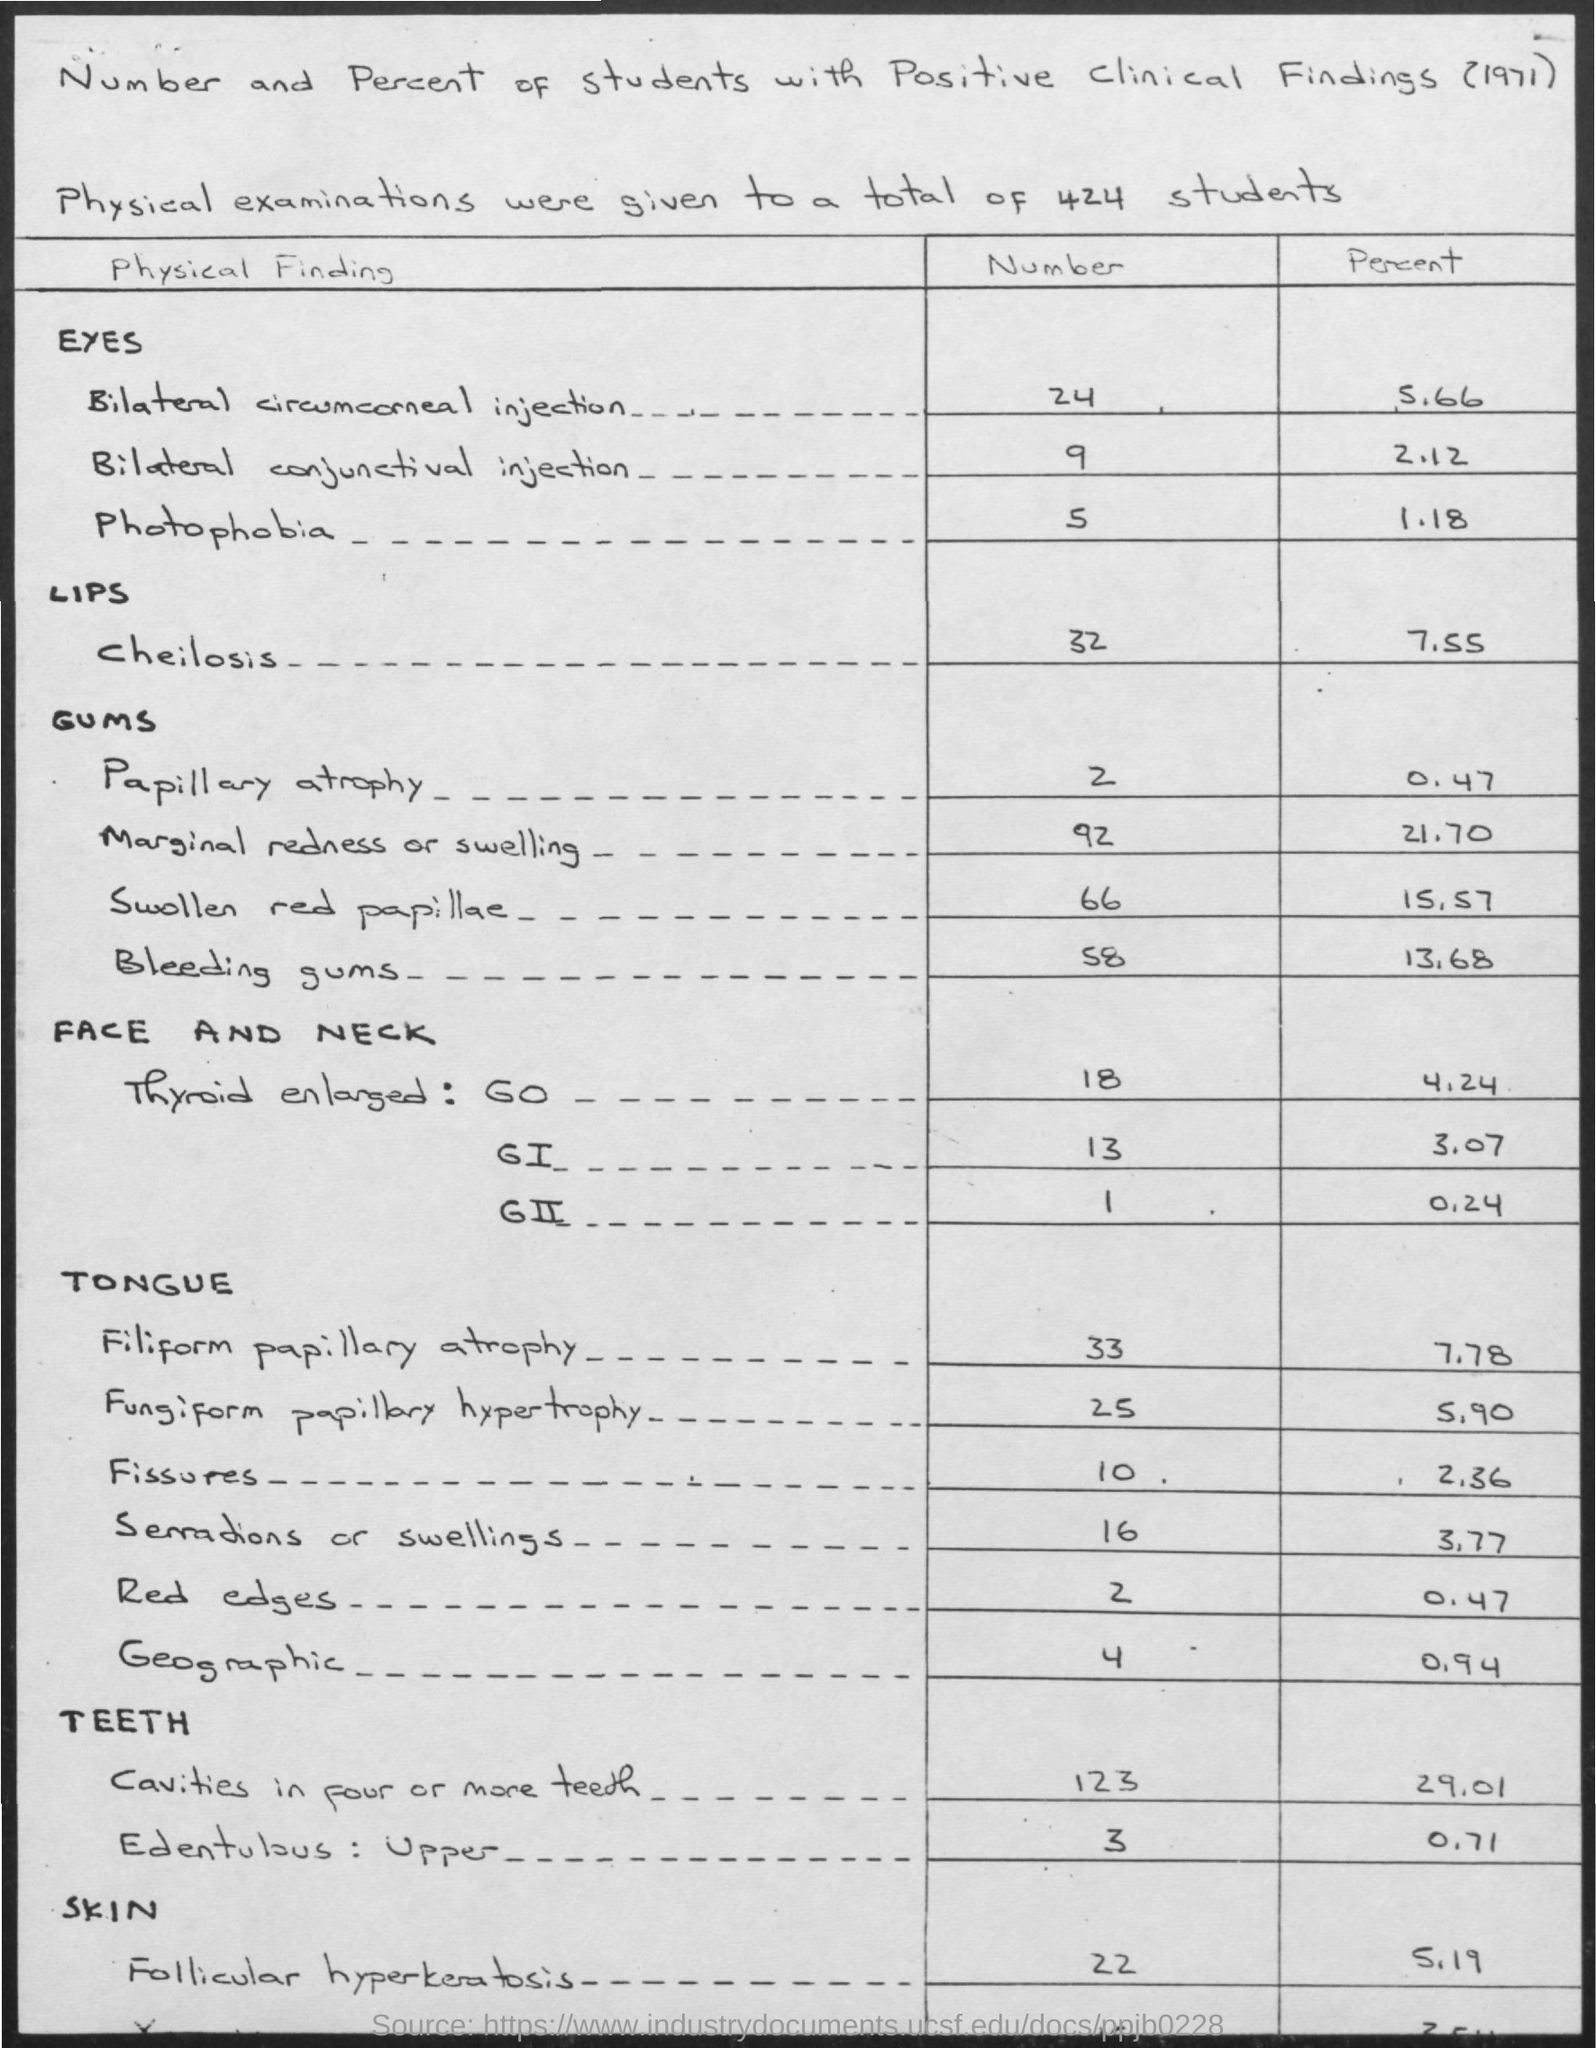What is the number of students?
Ensure brevity in your answer.  424. What is the year Mentioned in the document?
Keep it short and to the point. 1971. 